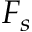<formula> <loc_0><loc_0><loc_500><loc_500>F _ { s }</formula> 